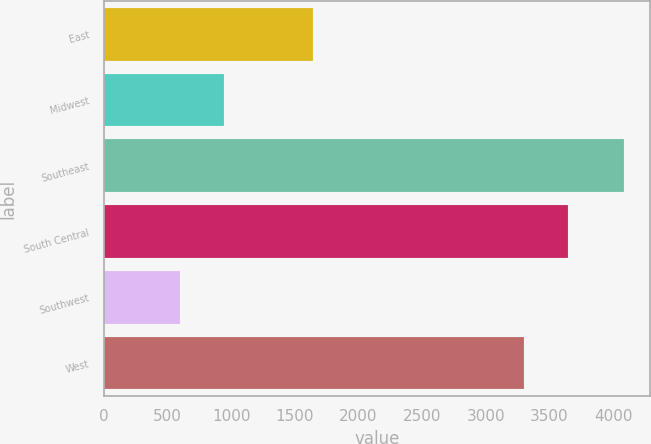Convert chart to OTSL. <chart><loc_0><loc_0><loc_500><loc_500><bar_chart><fcel>East<fcel>Midwest<fcel>Southeast<fcel>South Central<fcel>Southwest<fcel>West<nl><fcel>1640.1<fcel>946.51<fcel>4087.6<fcel>3645.71<fcel>597.5<fcel>3296.7<nl></chart> 